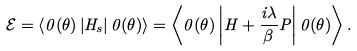<formula> <loc_0><loc_0><loc_500><loc_500>\mathcal { E } = \left \langle 0 ( \theta ) \left | H _ { s } \right | 0 ( \theta ) \right \rangle = \left \langle 0 ( \theta ) \left | H + \frac { i \lambda } { \beta } P \right | 0 ( \theta ) \right \rangle .</formula> 